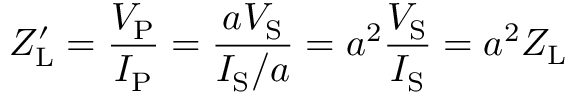<formula> <loc_0><loc_0><loc_500><loc_500>Z _ { L } ^ { \prime } = { \frac { V _ { P } } { I _ { P } } } = { \frac { a V _ { S } } { I _ { S } / a } } = a ^ { 2 } { \frac { V _ { S } } { I _ { S } } } = a ^ { 2 } { Z _ { L } }</formula> 